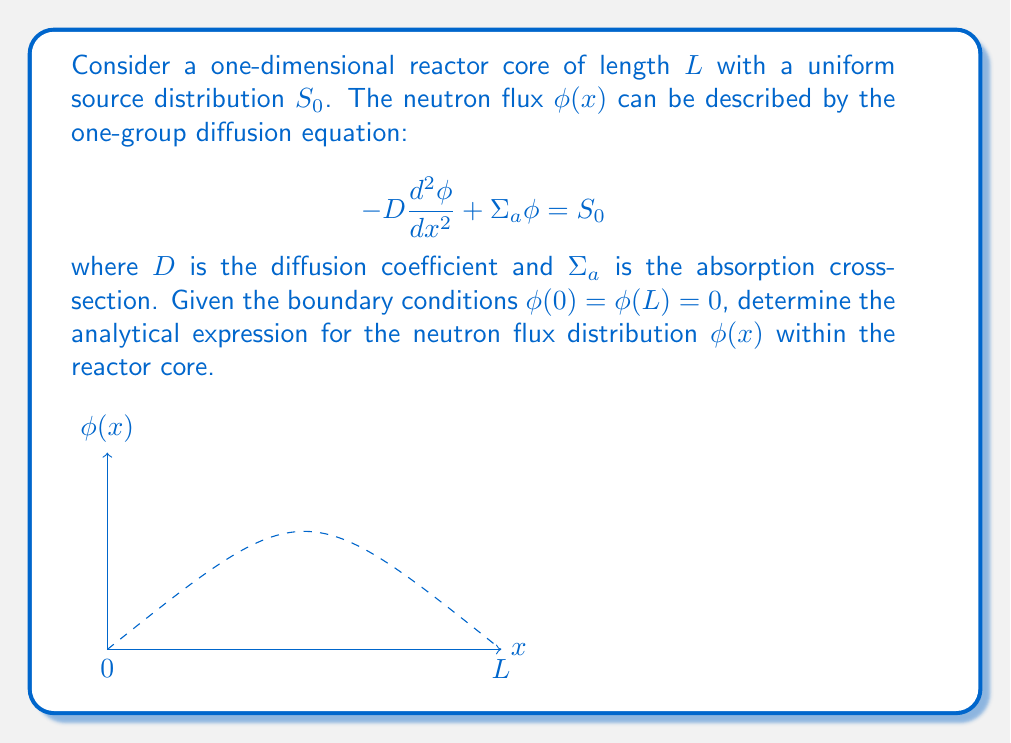Give your solution to this math problem. To solve this problem, we'll follow these steps:

1) The general solution to this inhomogeneous differential equation is the sum of the homogeneous solution and a particular solution:

   $\phi(x) = \phi_h(x) + \phi_p(x)$

2) The homogeneous solution satisfies:
   
   $$-D\frac{d^2\phi_h}{dx^2} + \Sigma_a\phi_h = 0$$
   
   This has the general solution:
   
   $\phi_h(x) = A\sinh(kx) + B\cosh(kx)$, where $k = \sqrt{\frac{\Sigma_a}{D}}$

3) A particular solution is a constant:
   
   $\phi_p(x) = \frac{S_0}{\Sigma_a}$

4) Therefore, the general solution is:
   
   $\phi(x) = A\sinh(kx) + B\cosh(kx) + \frac{S_0}{\Sigma_a}$

5) Apply the boundary conditions:
   
   At $x=0$: $\phi(0) = 0 = B + \frac{S_0}{\Sigma_a}$, so $B = -\frac{S_0}{\Sigma_a}$
   
   At $x=L$: $\phi(L) = 0 = A\sinh(kL) - \frac{S_0}{\Sigma_a}\cosh(kL) + \frac{S_0}{\Sigma_a}$

6) Solve for $A$:
   
   $A = \frac{S_0}{\Sigma_a} \cdot \frac{\cosh(kL)-1}{\sinh(kL)}$

7) Substitute these values back into the general solution:

   $\phi(x) = \frac{S_0}{\Sigma_a} \left[\frac{\cosh(kL)-1}{\sinh(kL)}\sinh(kx) - \cosh(kx) + 1\right]$

This is the analytical expression for the neutron flux distribution within the reactor core.
Answer: $\phi(x) = \frac{S_0}{\Sigma_a} \left[\frac{\cosh(kL)-1}{\sinh(kL)}\sinh(kx) - \cosh(kx) + 1\right]$, where $k = \sqrt{\frac{\Sigma_a}{D}}$ 